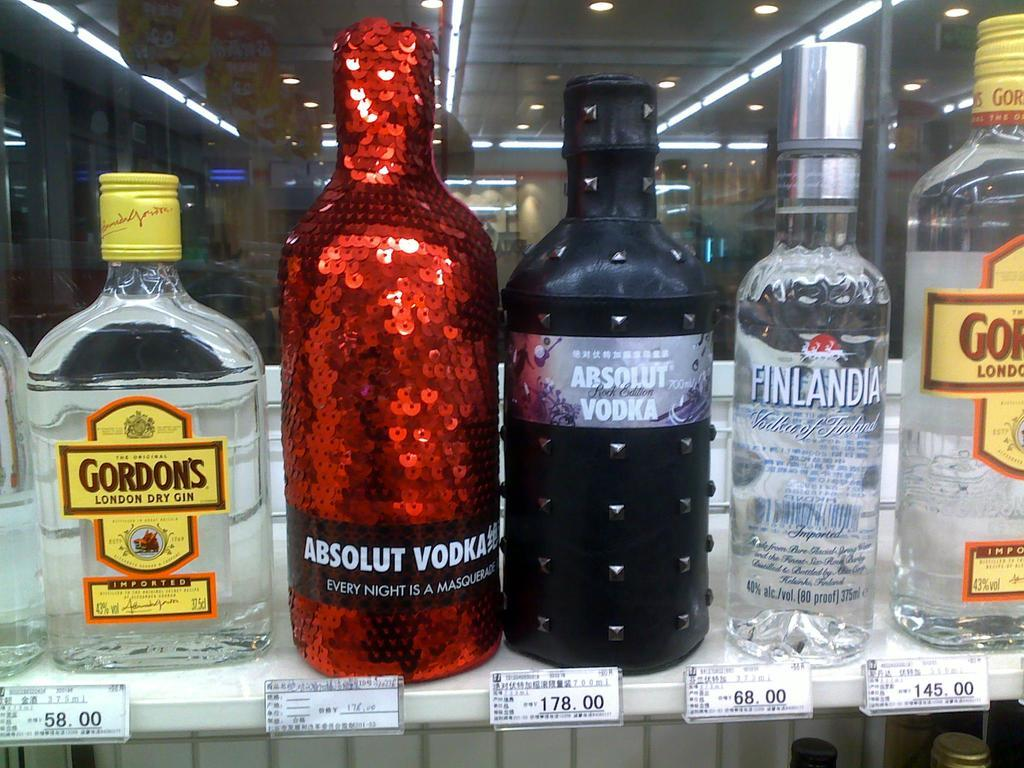<image>
Relay a brief, clear account of the picture shown. Bottles of alcohol including Absolut Vodka sold on a shelf. 